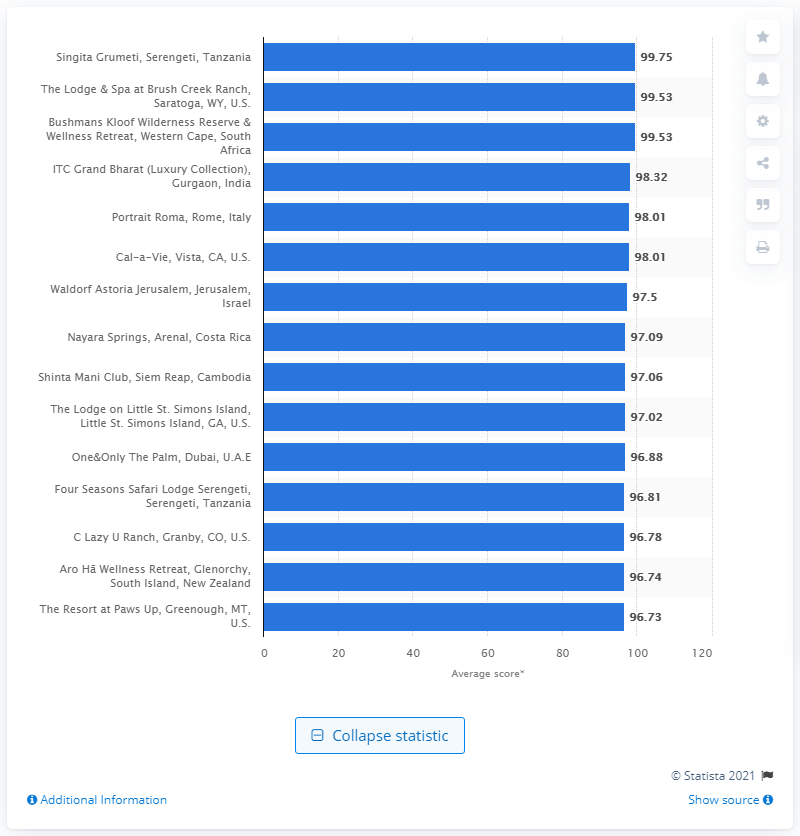List a handful of essential elements in this visual. Singita Grumeti scored 99.75 points. 